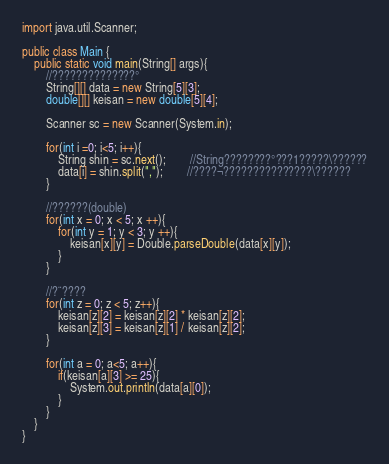<code> <loc_0><loc_0><loc_500><loc_500><_Java_>import java.util.Scanner;

public class Main {
	public static void main(String[] args){
		//??????????????°
		String[][] data = new String[5][3];
		double[][] keisan = new double[5][4];

		Scanner sc = new Scanner(System.in);

		for(int i =0; i<5; i++){
			String shin = sc.next();		//String????????°???1?????\??????
			data[i] = shin.split(",");		//????¬???????????????\??????
		}

		//??????(double)
		for(int x = 0; x < 5; x ++){
			for(int y = 1; y < 3; y ++){
				keisan[x][y] = Double.parseDouble(data[x][y]);
			}
		}

		//?¨????
		for(int z = 0; z < 5; z++){
			keisan[z][2] = keisan[z][2] * keisan[z][2];
			keisan[z][3] = keisan[z][1] / keisan[z][2];
		}

		for(int a = 0; a<5; a++){
			if(keisan[a][3] >= 25){
				System.out.println(data[a][0]);
			}
		}
	}
}</code> 